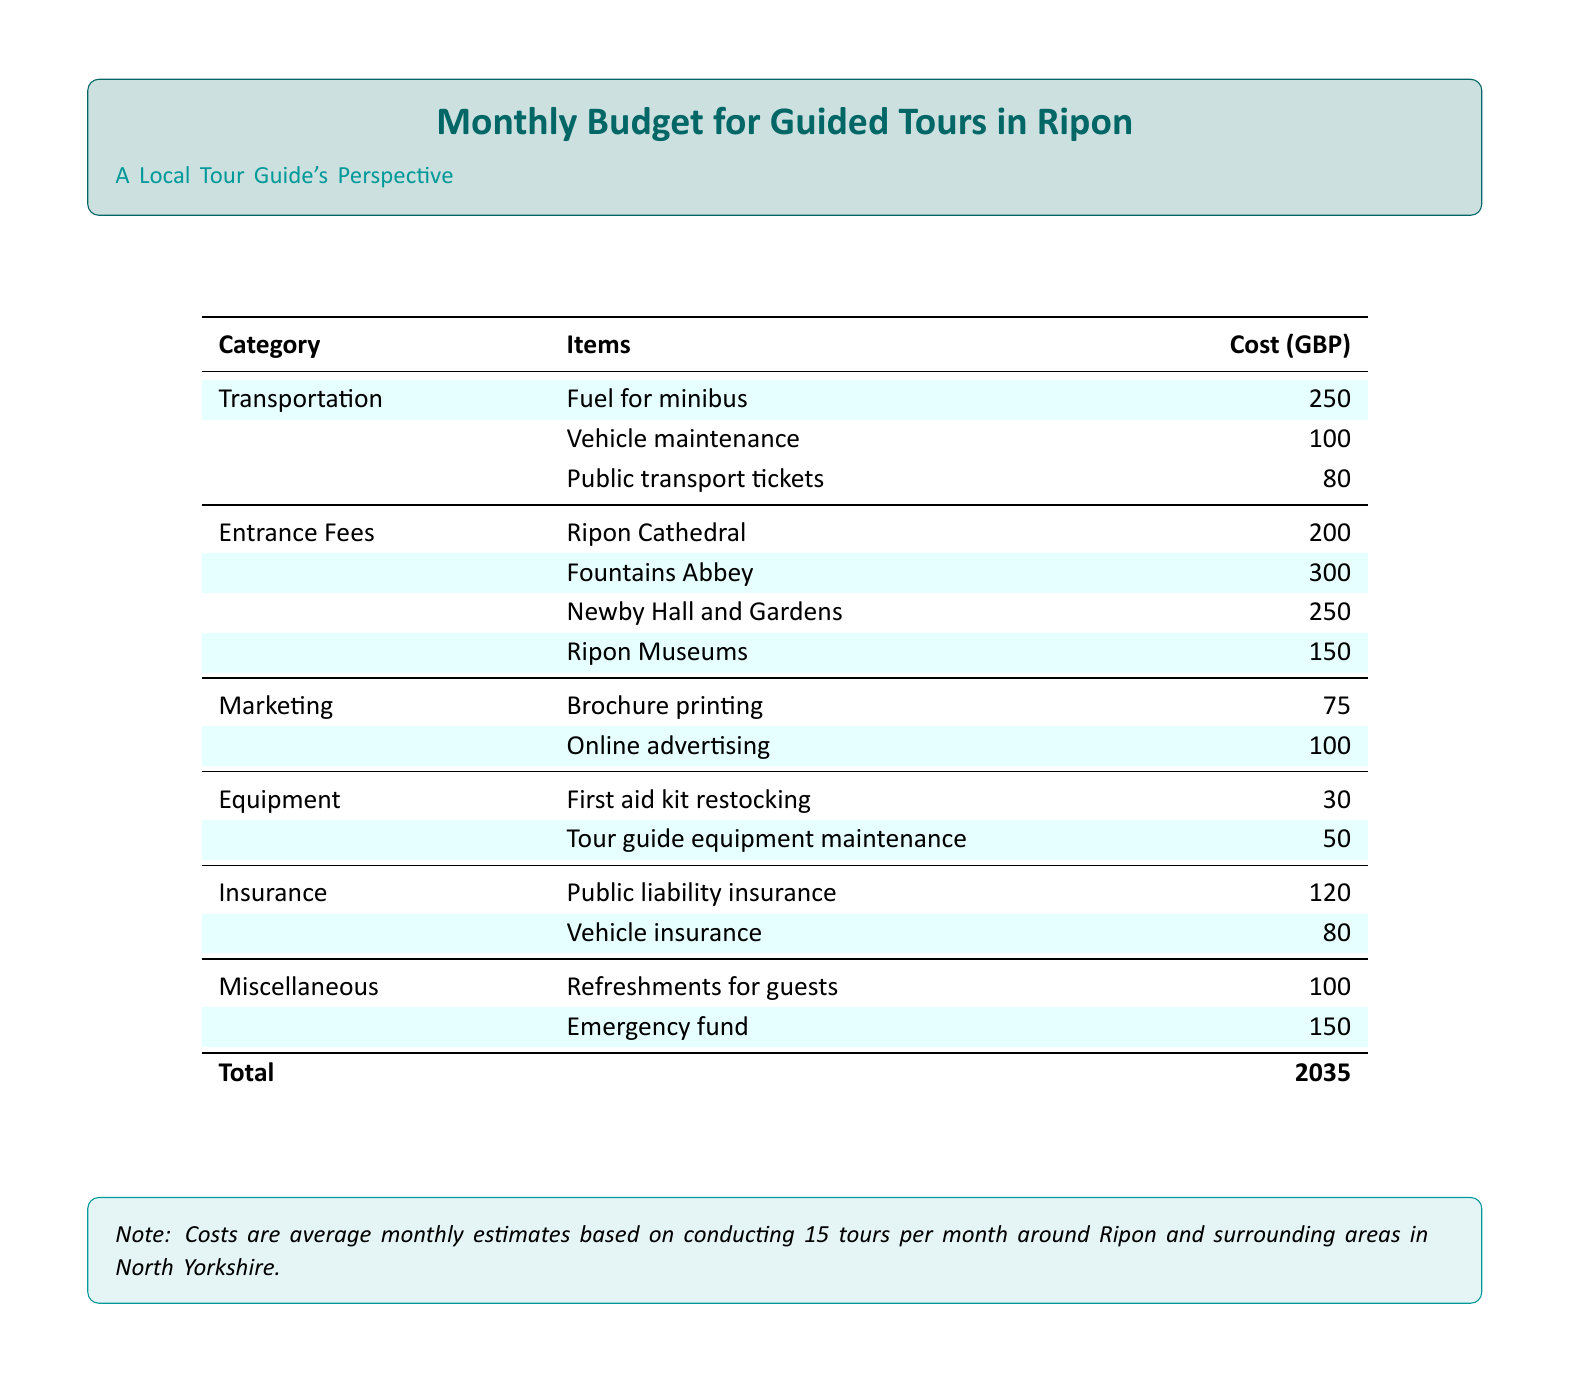what is the total cost for the monthly budget? The total cost is the sum of all expenses listed in the document, which amounts to 2035 GBP.
Answer: 2035 how much is allocated for fuel for the minibus? The document specifies that the cost for fuel for the minibus is listed under transportation.
Answer: 250 which attraction has the highest entrance fee? By comparing the entrance fees, Fountains Abbey has the highest fee of 300 GBP.
Answer: Fountains Abbey what is the cost for public liability insurance? The public liability insurance cost is detailed in the insurance category of the budget.
Answer: 120 how many tours are estimated to be conducted each month? The note at the bottom of the document mentions that 15 tours are estimated to be conducted per month.
Answer: 15 what is the total cost for marketing expenses? The marketing expenses are detailed, and their total can be calculated from brochure printing and online advertising costs.
Answer: 175 how much is budgeted for refreshments for guests? The miscellaneous category includes a specific line item for refreshments for guests.
Answer: 100 what is the budget for vehicle maintenance? The cost for vehicle maintenance is explicitly stated in the transportation category.
Answer: 100 how much is set aside for the emergency fund? The emergency fund is described in the miscellaneous section of the budget.
Answer: 150 